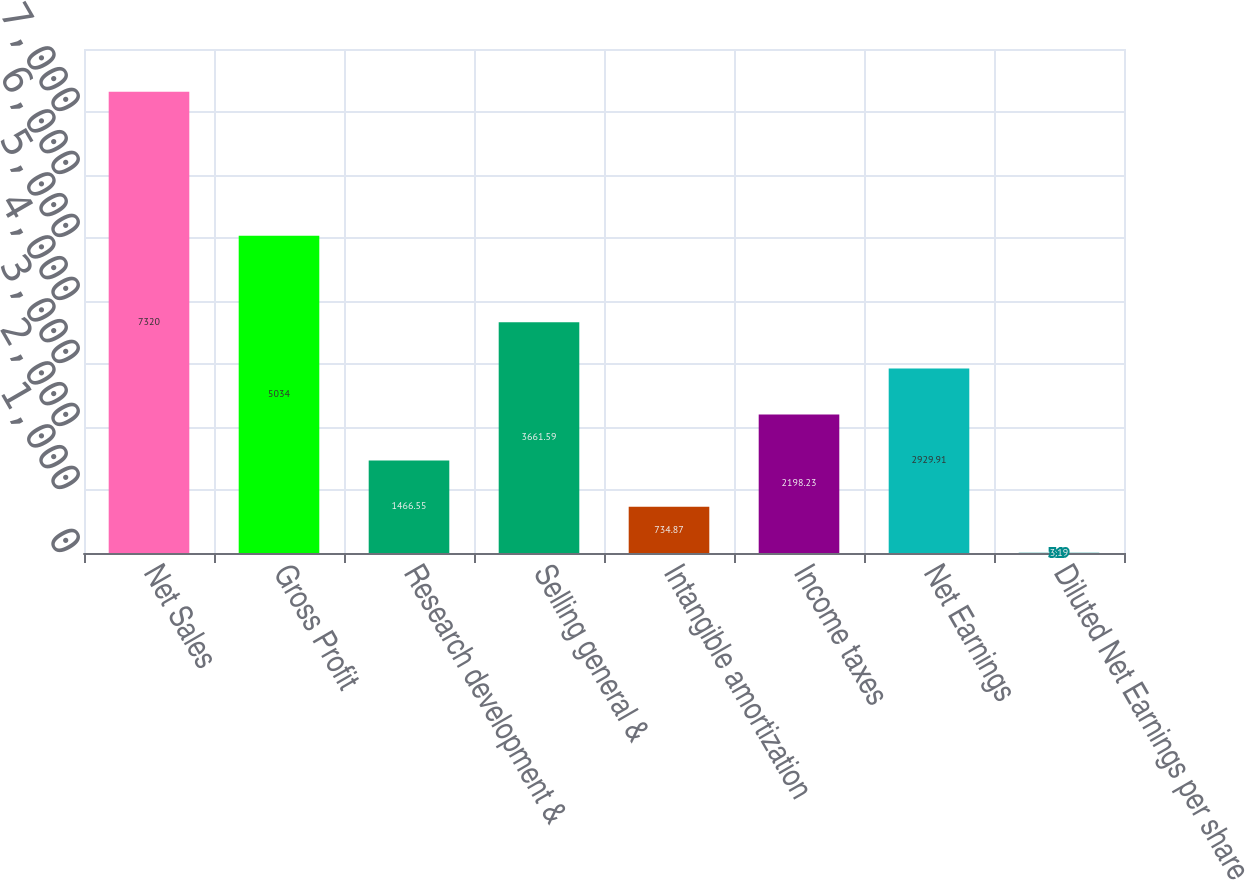Convert chart. <chart><loc_0><loc_0><loc_500><loc_500><bar_chart><fcel>Net Sales<fcel>Gross Profit<fcel>Research development &<fcel>Selling general &<fcel>Intangible amortization<fcel>Income taxes<fcel>Net Earnings<fcel>Diluted Net Earnings per share<nl><fcel>7320<fcel>5034<fcel>1466.55<fcel>3661.59<fcel>734.87<fcel>2198.23<fcel>2929.91<fcel>3.19<nl></chart> 